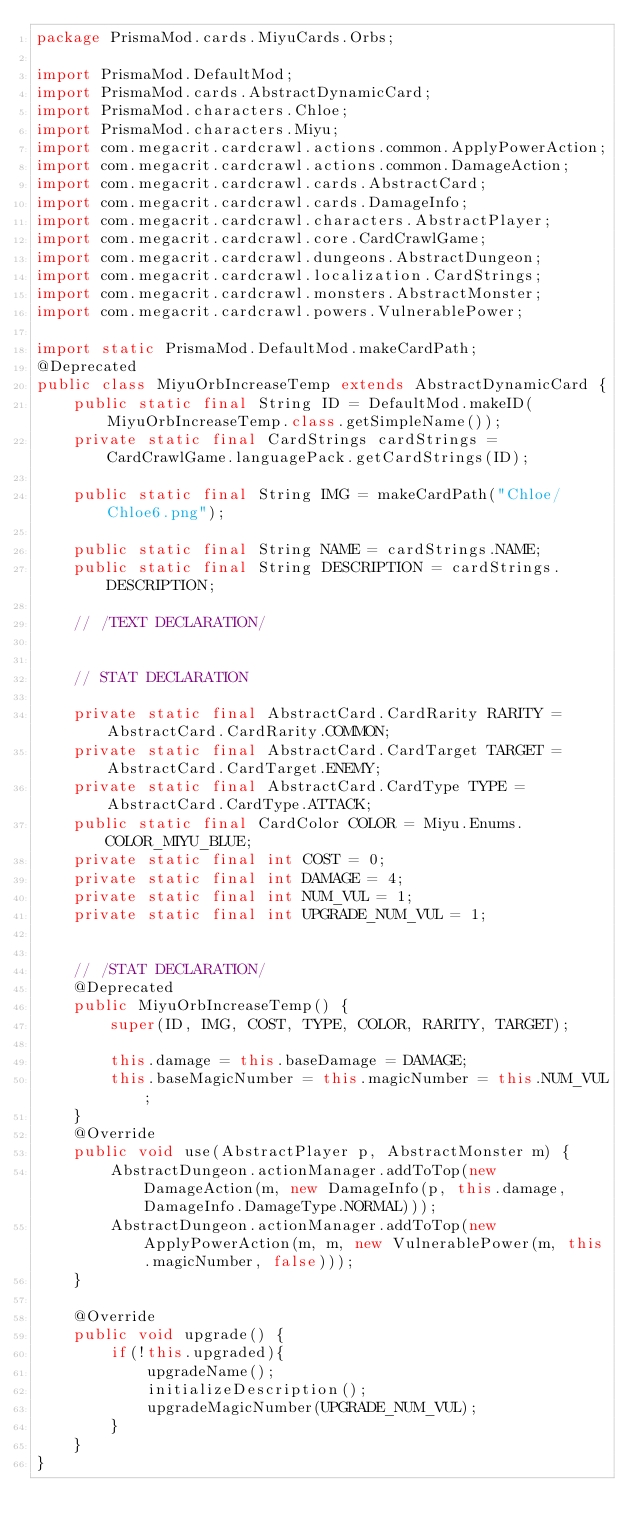<code> <loc_0><loc_0><loc_500><loc_500><_Java_>package PrismaMod.cards.MiyuCards.Orbs;

import PrismaMod.DefaultMod;
import PrismaMod.cards.AbstractDynamicCard;
import PrismaMod.characters.Chloe;
import PrismaMod.characters.Miyu;
import com.megacrit.cardcrawl.actions.common.ApplyPowerAction;
import com.megacrit.cardcrawl.actions.common.DamageAction;
import com.megacrit.cardcrawl.cards.AbstractCard;
import com.megacrit.cardcrawl.cards.DamageInfo;
import com.megacrit.cardcrawl.characters.AbstractPlayer;
import com.megacrit.cardcrawl.core.CardCrawlGame;
import com.megacrit.cardcrawl.dungeons.AbstractDungeon;
import com.megacrit.cardcrawl.localization.CardStrings;
import com.megacrit.cardcrawl.monsters.AbstractMonster;
import com.megacrit.cardcrawl.powers.VulnerablePower;

import static PrismaMod.DefaultMod.makeCardPath;
@Deprecated
public class MiyuOrbIncreaseTemp extends AbstractDynamicCard {
    public static final String ID = DefaultMod.makeID(MiyuOrbIncreaseTemp.class.getSimpleName());
    private static final CardStrings cardStrings = CardCrawlGame.languagePack.getCardStrings(ID);

    public static final String IMG = makeCardPath("Chloe/Chloe6.png");

    public static final String NAME = cardStrings.NAME;
    public static final String DESCRIPTION = cardStrings.DESCRIPTION;

    // /TEXT DECLARATION/


    // STAT DECLARATION

    private static final AbstractCard.CardRarity RARITY = AbstractCard.CardRarity.COMMON;
    private static final AbstractCard.CardTarget TARGET = AbstractCard.CardTarget.ENEMY;
    private static final AbstractCard.CardType TYPE = AbstractCard.CardType.ATTACK;
    public static final CardColor COLOR = Miyu.Enums.COLOR_MIYU_BLUE;
    private static final int COST = 0;
    private static final int DAMAGE = 4;
    private static final int NUM_VUL = 1;
    private static final int UPGRADE_NUM_VUL = 1;


    // /STAT DECLARATION/
    @Deprecated
    public MiyuOrbIncreaseTemp() {
        super(ID, IMG, COST, TYPE, COLOR, RARITY, TARGET);

        this.damage = this.baseDamage = DAMAGE;
        this.baseMagicNumber = this.magicNumber = this.NUM_VUL;
    }
    @Override
    public void use(AbstractPlayer p, AbstractMonster m) {
        AbstractDungeon.actionManager.addToTop(new DamageAction(m, new DamageInfo(p, this.damage, DamageInfo.DamageType.NORMAL)));
        AbstractDungeon.actionManager.addToTop(new ApplyPowerAction(m, m, new VulnerablePower(m, this.magicNumber, false)));
    }

    @Override
    public void upgrade() {
        if(!this.upgraded){
            upgradeName();
            initializeDescription();
            upgradeMagicNumber(UPGRADE_NUM_VUL);
        }
    }
}</code> 